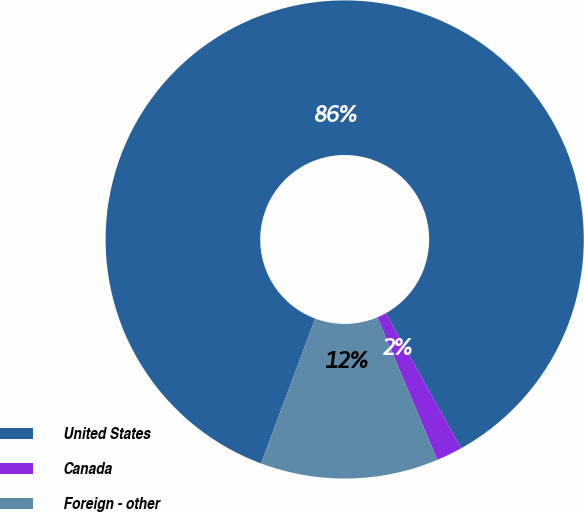Convert chart to OTSL. <chart><loc_0><loc_0><loc_500><loc_500><pie_chart><fcel>United States<fcel>Canada<fcel>Foreign - other<nl><fcel>86.21%<fcel>1.76%<fcel>12.02%<nl></chart> 